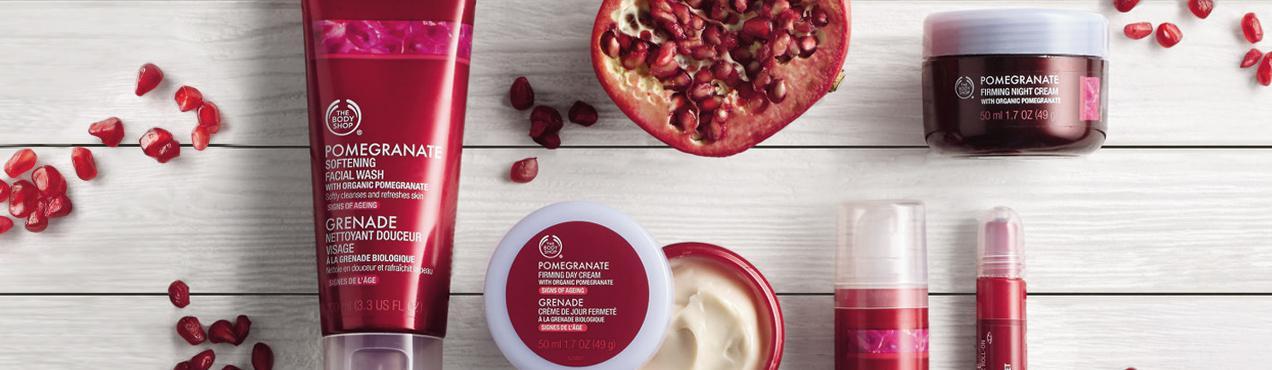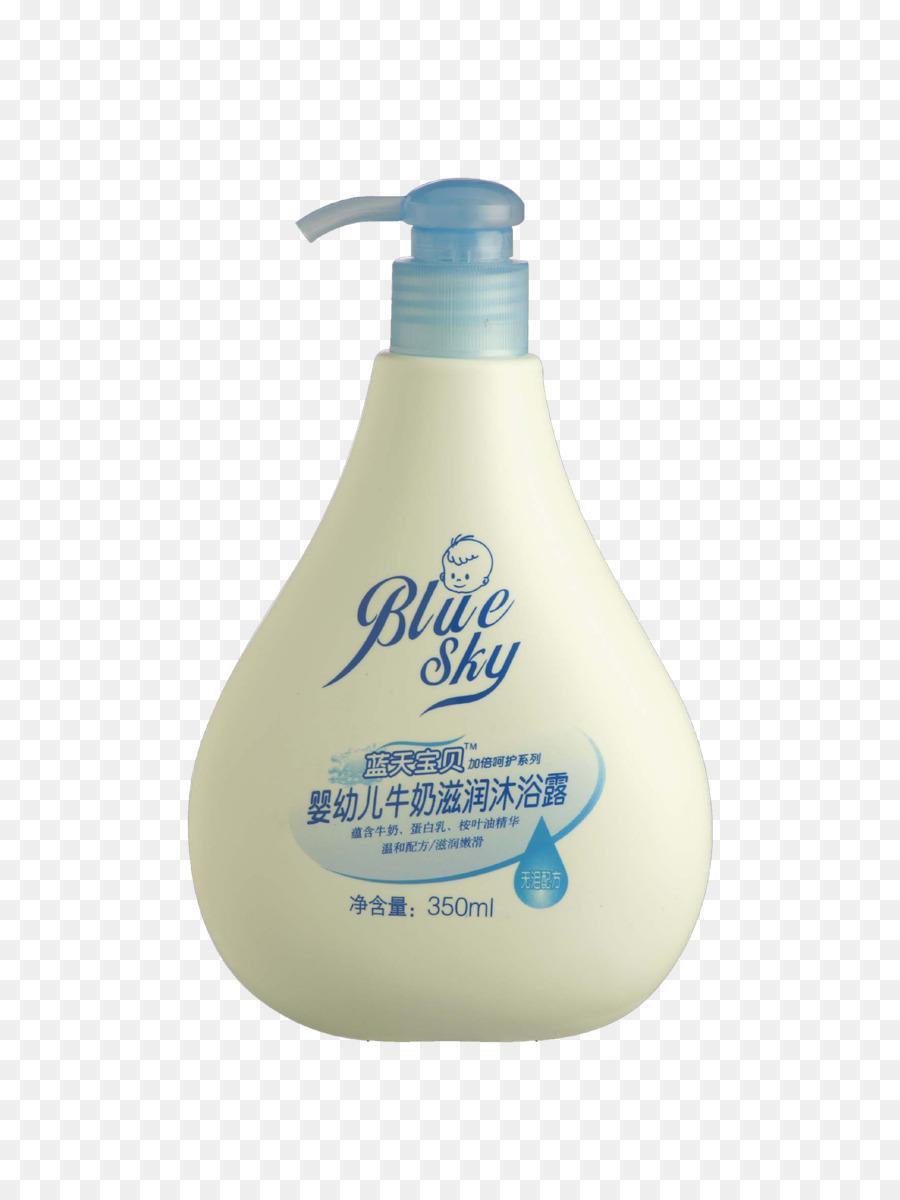The first image is the image on the left, the second image is the image on the right. Assess this claim about the two images: "Some items are laying flat.". Correct or not? Answer yes or no. Yes. The first image is the image on the left, the second image is the image on the right. Assess this claim about the two images: "One image contains a pump-top bottle, but no image contains more than one pump-top bottle.". Correct or not? Answer yes or no. Yes. 